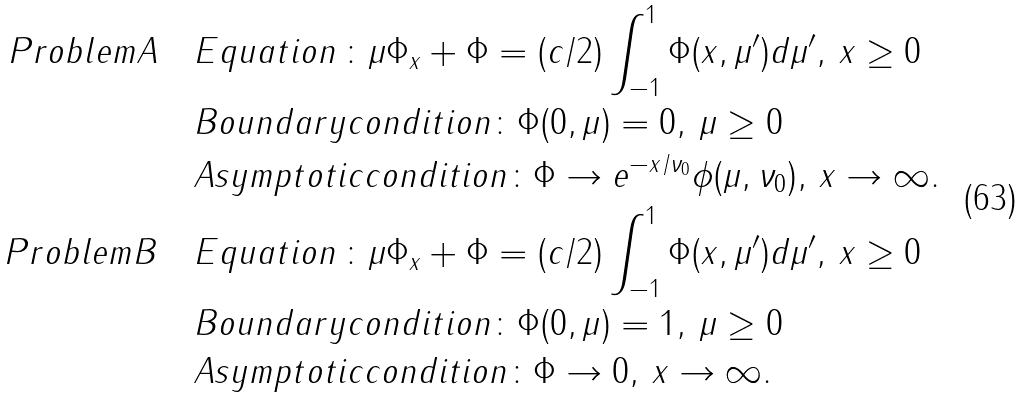<formula> <loc_0><loc_0><loc_500><loc_500>P r o b l e m A \quad & E q u a t i o n \, \colon { \mu \Phi _ { x } + \Phi = ( c / 2 ) \int _ { - 1 } ^ { 1 } \Phi ( x , \mu ^ { \prime } ) d \mu ^ { \prime } , \, x \geq 0 } \\ & B o u n d a r y c o n d i t i o n \colon \Phi ( 0 , \mu ) = 0 , \, \mu \geq 0 \\ & A s y m p t o t i c c o n d i t i o n \colon \Phi \rightarrow e ^ { - x / \nu _ { 0 } } \phi ( \mu , \nu _ { 0 } ) , \, x \rightarrow \infty . \\ P r o b l e m B \quad & E q u a t i o n \, \colon { \mu \Phi _ { x } + \Phi = ( c / 2 ) \int _ { - 1 } ^ { 1 } \Phi ( x , \mu ^ { \prime } ) d \mu ^ { \prime } , \, x \geq 0 } \\ & B o u n d a r y c o n d i t i o n \colon \Phi ( 0 , \mu ) = 1 , \, \mu \geq 0 \\ & A s y m p t o t i c c o n d i t i o n \colon \Phi \rightarrow 0 , \, x \rightarrow \infty .</formula> 